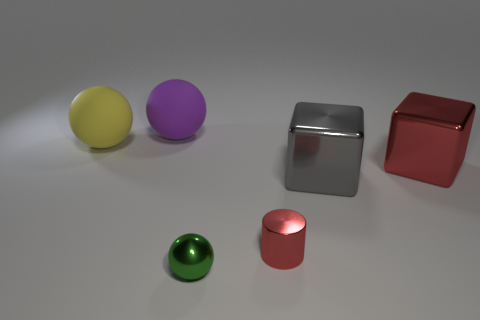Add 2 large cyan matte cylinders. How many objects exist? 8 Subtract all cylinders. How many objects are left? 5 Subtract all large red metal things. Subtract all tiny shiny balls. How many objects are left? 4 Add 4 red things. How many red things are left? 6 Add 5 big red cylinders. How many big red cylinders exist? 5 Subtract 0 red balls. How many objects are left? 6 